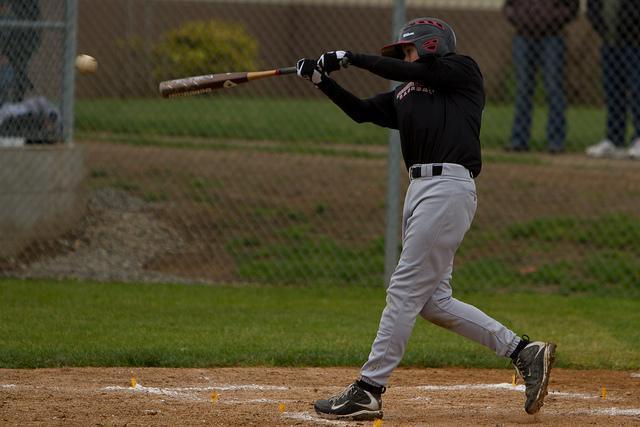How many people are there?
Give a very brief answer. 3. 